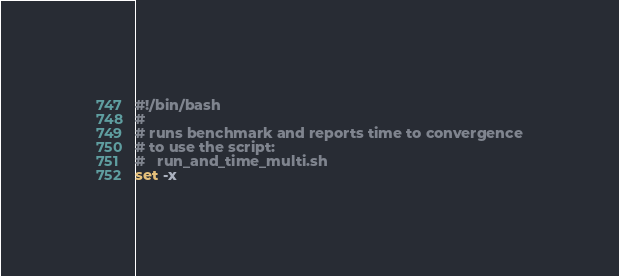<code> <loc_0><loc_0><loc_500><loc_500><_Bash_>#!/bin/bash
#
# runs benchmark and reports time to convergence
# to use the script:
#   run_and_time_multi.sh
set -x
</code> 